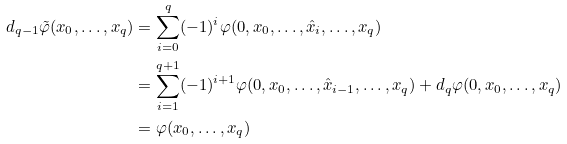Convert formula to latex. <formula><loc_0><loc_0><loc_500><loc_500>d _ { q - 1 } \tilde { \varphi } ( x _ { 0 } , \dots , x _ { q } ) & = \sum _ { i = 0 } ^ { q } ( - 1 ) ^ { i } \varphi ( 0 , x _ { 0 } , \dots , \hat { x } _ { i } , \dots , x _ { q } ) \\ & = \sum _ { i = 1 } ^ { q + 1 } ( - 1 ) ^ { i + 1 } \varphi ( 0 , x _ { 0 } , \dots , \hat { x } _ { i - 1 } , \dots , x _ { q } ) + d _ { q } \varphi ( 0 , x _ { 0 } , \dots , x _ { q } ) \\ & = \varphi ( x _ { 0 } , \dots , x _ { q } )</formula> 